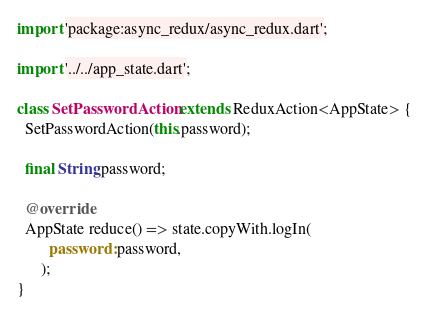Convert code to text. <code><loc_0><loc_0><loc_500><loc_500><_Dart_>import 'package:async_redux/async_redux.dart';

import '../../app_state.dart';

class SetPasswordAction extends ReduxAction<AppState> {
  SetPasswordAction(this.password);

  final String password;

  @override
  AppState reduce() => state.copyWith.logIn(
        password: password,
      );
}
</code> 